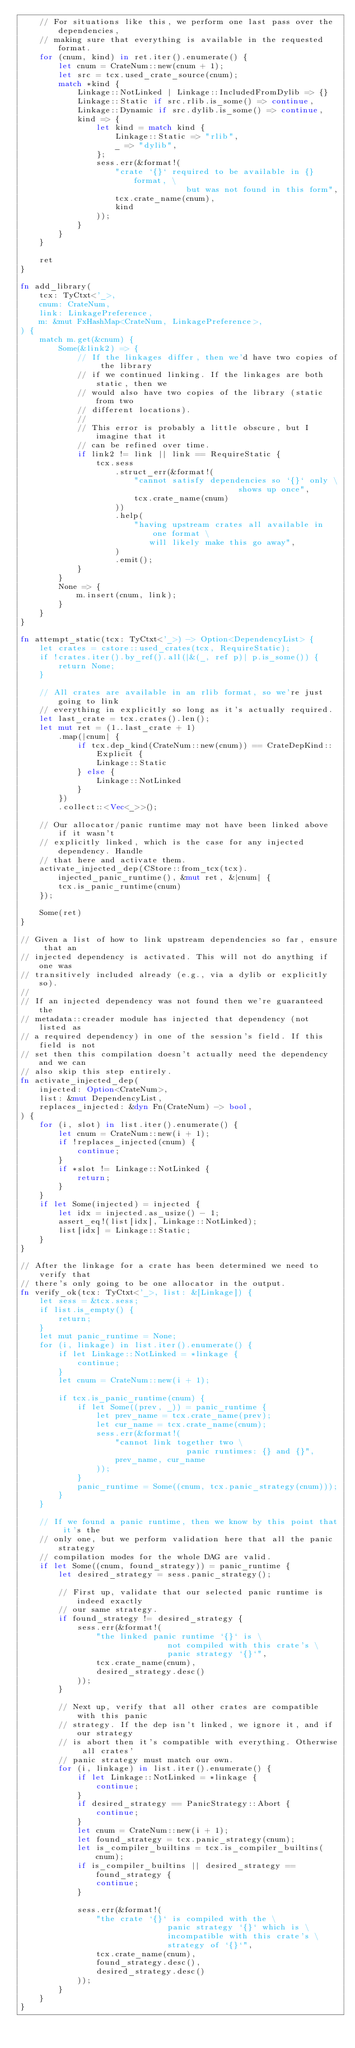<code> <loc_0><loc_0><loc_500><loc_500><_Rust_>    // For situations like this, we perform one last pass over the dependencies,
    // making sure that everything is available in the requested format.
    for (cnum, kind) in ret.iter().enumerate() {
        let cnum = CrateNum::new(cnum + 1);
        let src = tcx.used_crate_source(cnum);
        match *kind {
            Linkage::NotLinked | Linkage::IncludedFromDylib => {}
            Linkage::Static if src.rlib.is_some() => continue,
            Linkage::Dynamic if src.dylib.is_some() => continue,
            kind => {
                let kind = match kind {
                    Linkage::Static => "rlib",
                    _ => "dylib",
                };
                sess.err(&format!(
                    "crate `{}` required to be available in {} format, \
                                   but was not found in this form",
                    tcx.crate_name(cnum),
                    kind
                ));
            }
        }
    }

    ret
}

fn add_library(
    tcx: TyCtxt<'_>,
    cnum: CrateNum,
    link: LinkagePreference,
    m: &mut FxHashMap<CrateNum, LinkagePreference>,
) {
    match m.get(&cnum) {
        Some(&link2) => {
            // If the linkages differ, then we'd have two copies of the library
            // if we continued linking. If the linkages are both static, then we
            // would also have two copies of the library (static from two
            // different locations).
            //
            // This error is probably a little obscure, but I imagine that it
            // can be refined over time.
            if link2 != link || link == RequireStatic {
                tcx.sess
                    .struct_err(&format!(
                        "cannot satisfy dependencies so `{}` only \
                                              shows up once",
                        tcx.crate_name(cnum)
                    ))
                    .help(
                        "having upstream crates all available in one format \
                           will likely make this go away",
                    )
                    .emit();
            }
        }
        None => {
            m.insert(cnum, link);
        }
    }
}

fn attempt_static(tcx: TyCtxt<'_>) -> Option<DependencyList> {
    let crates = cstore::used_crates(tcx, RequireStatic);
    if !crates.iter().by_ref().all(|&(_, ref p)| p.is_some()) {
        return None;
    }

    // All crates are available in an rlib format, so we're just going to link
    // everything in explicitly so long as it's actually required.
    let last_crate = tcx.crates().len();
    let mut ret = (1..last_crate + 1)
        .map(|cnum| {
            if tcx.dep_kind(CrateNum::new(cnum)) == CrateDepKind::Explicit {
                Linkage::Static
            } else {
                Linkage::NotLinked
            }
        })
        .collect::<Vec<_>>();

    // Our allocator/panic runtime may not have been linked above if it wasn't
    // explicitly linked, which is the case for any injected dependency. Handle
    // that here and activate them.
    activate_injected_dep(CStore::from_tcx(tcx).injected_panic_runtime(), &mut ret, &|cnum| {
        tcx.is_panic_runtime(cnum)
    });

    Some(ret)
}

// Given a list of how to link upstream dependencies so far, ensure that an
// injected dependency is activated. This will not do anything if one was
// transitively included already (e.g., via a dylib or explicitly so).
//
// If an injected dependency was not found then we're guaranteed the
// metadata::creader module has injected that dependency (not listed as
// a required dependency) in one of the session's field. If this field is not
// set then this compilation doesn't actually need the dependency and we can
// also skip this step entirely.
fn activate_injected_dep(
    injected: Option<CrateNum>,
    list: &mut DependencyList,
    replaces_injected: &dyn Fn(CrateNum) -> bool,
) {
    for (i, slot) in list.iter().enumerate() {
        let cnum = CrateNum::new(i + 1);
        if !replaces_injected(cnum) {
            continue;
        }
        if *slot != Linkage::NotLinked {
            return;
        }
    }
    if let Some(injected) = injected {
        let idx = injected.as_usize() - 1;
        assert_eq!(list[idx], Linkage::NotLinked);
        list[idx] = Linkage::Static;
    }
}

// After the linkage for a crate has been determined we need to verify that
// there's only going to be one allocator in the output.
fn verify_ok(tcx: TyCtxt<'_>, list: &[Linkage]) {
    let sess = &tcx.sess;
    if list.is_empty() {
        return;
    }
    let mut panic_runtime = None;
    for (i, linkage) in list.iter().enumerate() {
        if let Linkage::NotLinked = *linkage {
            continue;
        }
        let cnum = CrateNum::new(i + 1);

        if tcx.is_panic_runtime(cnum) {
            if let Some((prev, _)) = panic_runtime {
                let prev_name = tcx.crate_name(prev);
                let cur_name = tcx.crate_name(cnum);
                sess.err(&format!(
                    "cannot link together two \
                                   panic runtimes: {} and {}",
                    prev_name, cur_name
                ));
            }
            panic_runtime = Some((cnum, tcx.panic_strategy(cnum)));
        }
    }

    // If we found a panic runtime, then we know by this point that it's the
    // only one, but we perform validation here that all the panic strategy
    // compilation modes for the whole DAG are valid.
    if let Some((cnum, found_strategy)) = panic_runtime {
        let desired_strategy = sess.panic_strategy();

        // First up, validate that our selected panic runtime is indeed exactly
        // our same strategy.
        if found_strategy != desired_strategy {
            sess.err(&format!(
                "the linked panic runtime `{}` is \
                               not compiled with this crate's \
                               panic strategy `{}`",
                tcx.crate_name(cnum),
                desired_strategy.desc()
            ));
        }

        // Next up, verify that all other crates are compatible with this panic
        // strategy. If the dep isn't linked, we ignore it, and if our strategy
        // is abort then it's compatible with everything. Otherwise all crates'
        // panic strategy must match our own.
        for (i, linkage) in list.iter().enumerate() {
            if let Linkage::NotLinked = *linkage {
                continue;
            }
            if desired_strategy == PanicStrategy::Abort {
                continue;
            }
            let cnum = CrateNum::new(i + 1);
            let found_strategy = tcx.panic_strategy(cnum);
            let is_compiler_builtins = tcx.is_compiler_builtins(cnum);
            if is_compiler_builtins || desired_strategy == found_strategy {
                continue;
            }

            sess.err(&format!(
                "the crate `{}` is compiled with the \
                               panic strategy `{}` which is \
                               incompatible with this crate's \
                               strategy of `{}`",
                tcx.crate_name(cnum),
                found_strategy.desc(),
                desired_strategy.desc()
            ));
        }
    }
}
</code> 